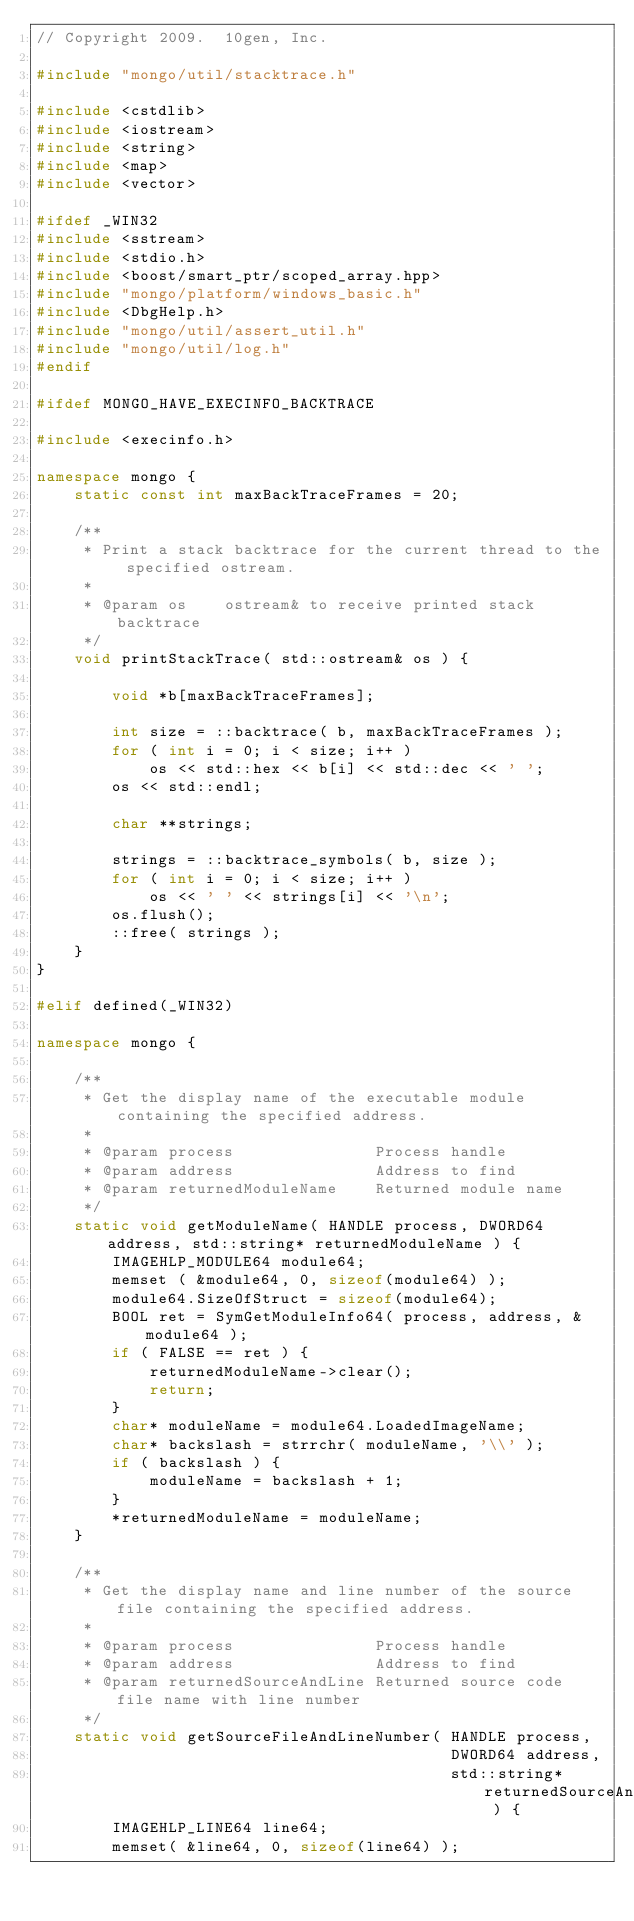Convert code to text. <code><loc_0><loc_0><loc_500><loc_500><_C++_>// Copyright 2009.  10gen, Inc.

#include "mongo/util/stacktrace.h"

#include <cstdlib>
#include <iostream>
#include <string>
#include <map>
#include <vector>

#ifdef _WIN32
#include <sstream>
#include <stdio.h>
#include <boost/smart_ptr/scoped_array.hpp>
#include "mongo/platform/windows_basic.h"
#include <DbgHelp.h>
#include "mongo/util/assert_util.h"
#include "mongo/util/log.h"
#endif

#ifdef MONGO_HAVE_EXECINFO_BACKTRACE

#include <execinfo.h>

namespace mongo {
    static const int maxBackTraceFrames = 20;

    /**
     * Print a stack backtrace for the current thread to the specified ostream.
     * 
     * @param os    ostream& to receive printed stack backtrace
     */
    void printStackTrace( std::ostream& os ) {
        
        void *b[maxBackTraceFrames];
        
        int size = ::backtrace( b, maxBackTraceFrames );
        for ( int i = 0; i < size; i++ )
            os << std::hex << b[i] << std::dec << ' ';
        os << std::endl;
        
        char **strings;
        
        strings = ::backtrace_symbols( b, size );
        for ( int i = 0; i < size; i++ )
            os << ' ' << strings[i] << '\n';
        os.flush();
        ::free( strings );
    }
}

#elif defined(_WIN32)

namespace mongo {

    /**
     * Get the display name of the executable module containing the specified address.
     * 
     * @param process               Process handle
     * @param address               Address to find
     * @param returnedModuleName    Returned module name
     */
    static void getModuleName( HANDLE process, DWORD64 address, std::string* returnedModuleName ) {
        IMAGEHLP_MODULE64 module64;
        memset ( &module64, 0, sizeof(module64) );
        module64.SizeOfStruct = sizeof(module64);
        BOOL ret = SymGetModuleInfo64( process, address, &module64 );
        if ( FALSE == ret ) {
            returnedModuleName->clear();
            return;
        }
        char* moduleName = module64.LoadedImageName;
        char* backslash = strrchr( moduleName, '\\' );
        if ( backslash ) {
            moduleName = backslash + 1;
        }
        *returnedModuleName = moduleName;
    }

    /**
     * Get the display name and line number of the source file containing the specified address.
     * 
     * @param process               Process handle
     * @param address               Address to find
     * @param returnedSourceAndLine Returned source code file name with line number
     */
    static void getSourceFileAndLineNumber( HANDLE process,
                                            DWORD64 address,
                                            std::string* returnedSourceAndLine ) {
        IMAGEHLP_LINE64 line64;
        memset( &line64, 0, sizeof(line64) );</code> 